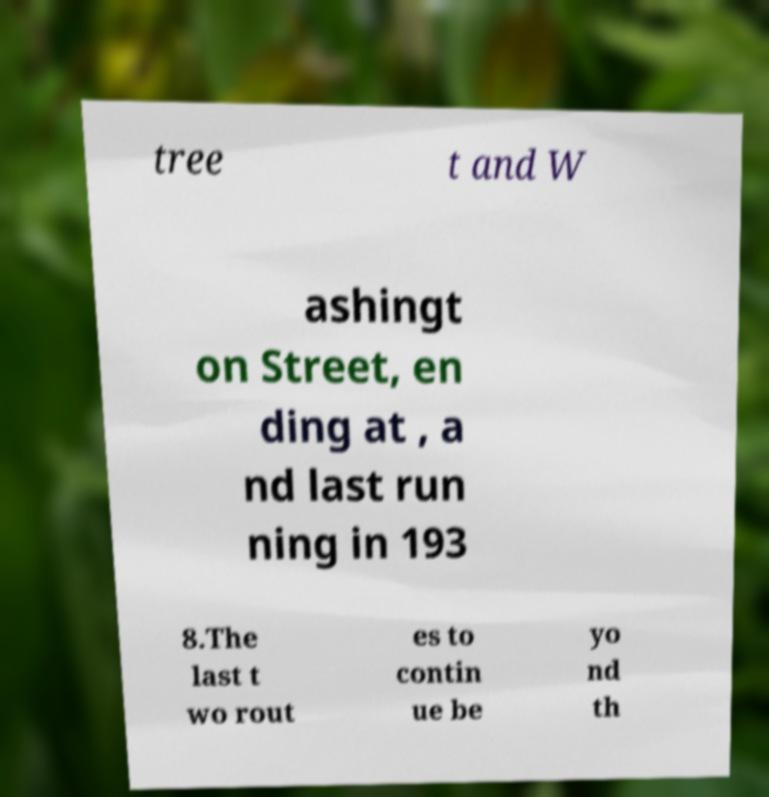Can you accurately transcribe the text from the provided image for me? tree t and W ashingt on Street, en ding at , a nd last run ning in 193 8.The last t wo rout es to contin ue be yo nd th 